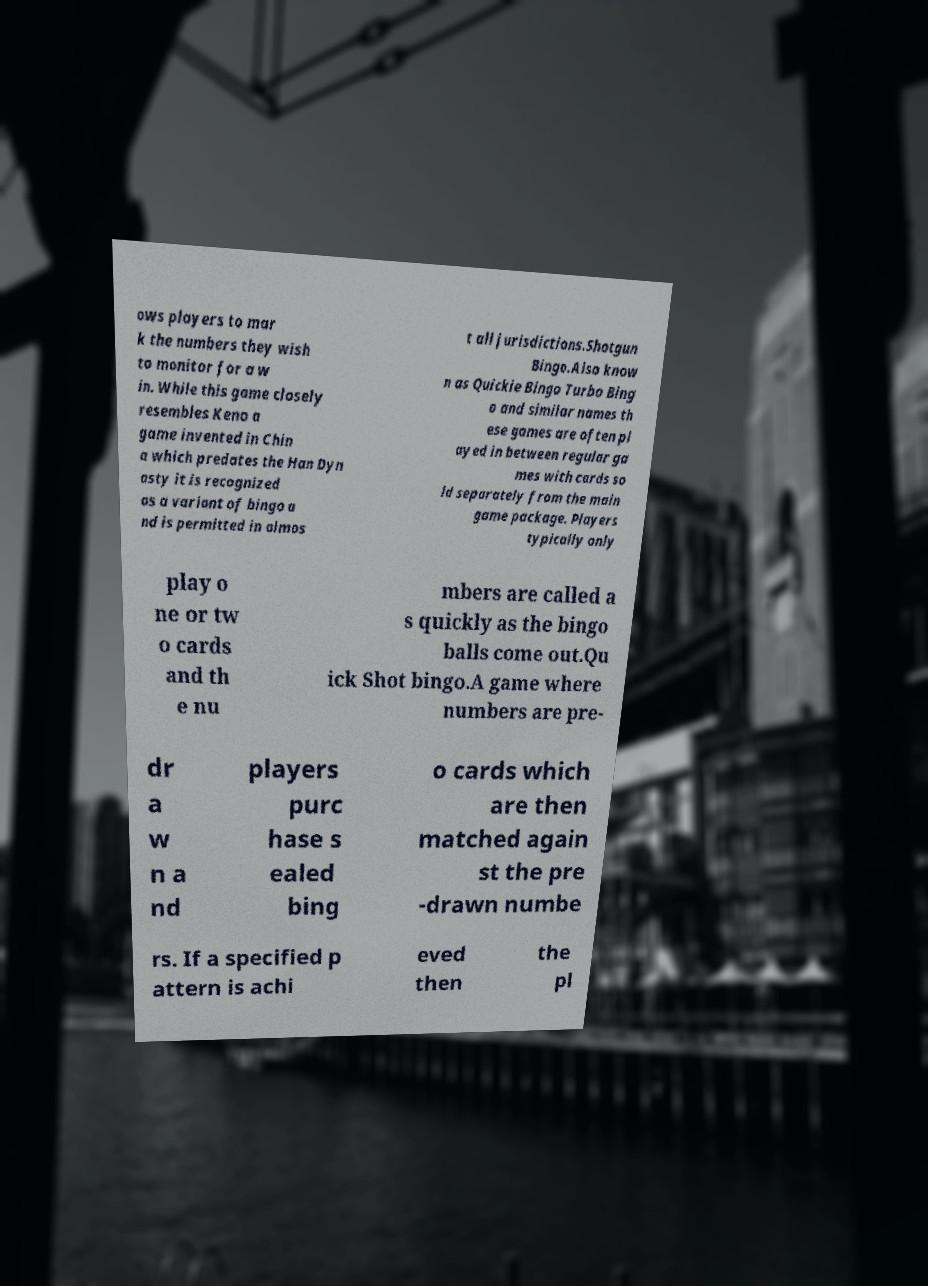Please read and relay the text visible in this image. What does it say? ows players to mar k the numbers they wish to monitor for a w in. While this game closely resembles Keno a game invented in Chin a which predates the Han Dyn asty it is recognized as a variant of bingo a nd is permitted in almos t all jurisdictions.Shotgun Bingo.Also know n as Quickie Bingo Turbo Bing o and similar names th ese games are often pl ayed in between regular ga mes with cards so ld separately from the main game package. Players typically only play o ne or tw o cards and th e nu mbers are called a s quickly as the bingo balls come out.Qu ick Shot bingo.A game where numbers are pre- dr a w n a nd players purc hase s ealed bing o cards which are then matched again st the pre -drawn numbe rs. If a specified p attern is achi eved then the pl 